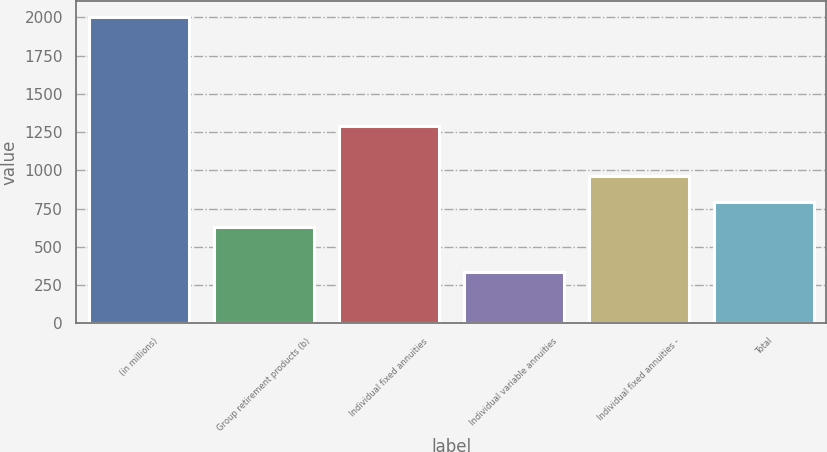<chart> <loc_0><loc_0><loc_500><loc_500><bar_chart><fcel>(in millions)<fcel>Group retirement products (b)<fcel>Individual fixed annuities<fcel>Individual variable annuities<fcel>Individual fixed annuities -<fcel>Total<nl><fcel>2005<fcel>628<fcel>1288<fcel>336<fcel>961.8<fcel>794.9<nl></chart> 